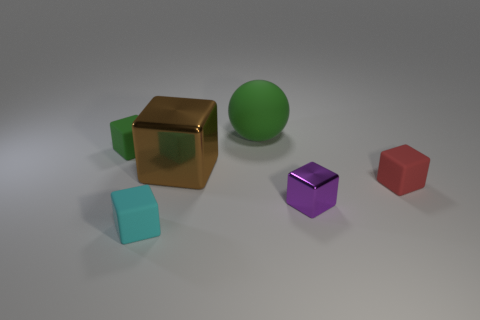Are there any other things that are the same shape as the large green rubber thing?
Keep it short and to the point. No. There is a block that is the same color as the matte sphere; what material is it?
Your answer should be very brief. Rubber. What shape is the shiny thing behind the matte block on the right side of the small purple thing?
Ensure brevity in your answer.  Cube. Is there a large brown object of the same shape as the small metal object?
Keep it short and to the point. Yes. Does the ball have the same color as the tiny thing left of the small cyan block?
Give a very brief answer. Yes. What size is the block that is the same color as the big sphere?
Your response must be concise. Small. Is there a red matte block that has the same size as the cyan rubber object?
Give a very brief answer. Yes. Does the sphere have the same material as the object to the left of the small cyan rubber cube?
Your response must be concise. Yes. Are there more small green blocks than small blue metal things?
Your answer should be compact. Yes. What number of cubes are brown metallic objects or matte objects?
Your answer should be compact. 4. 